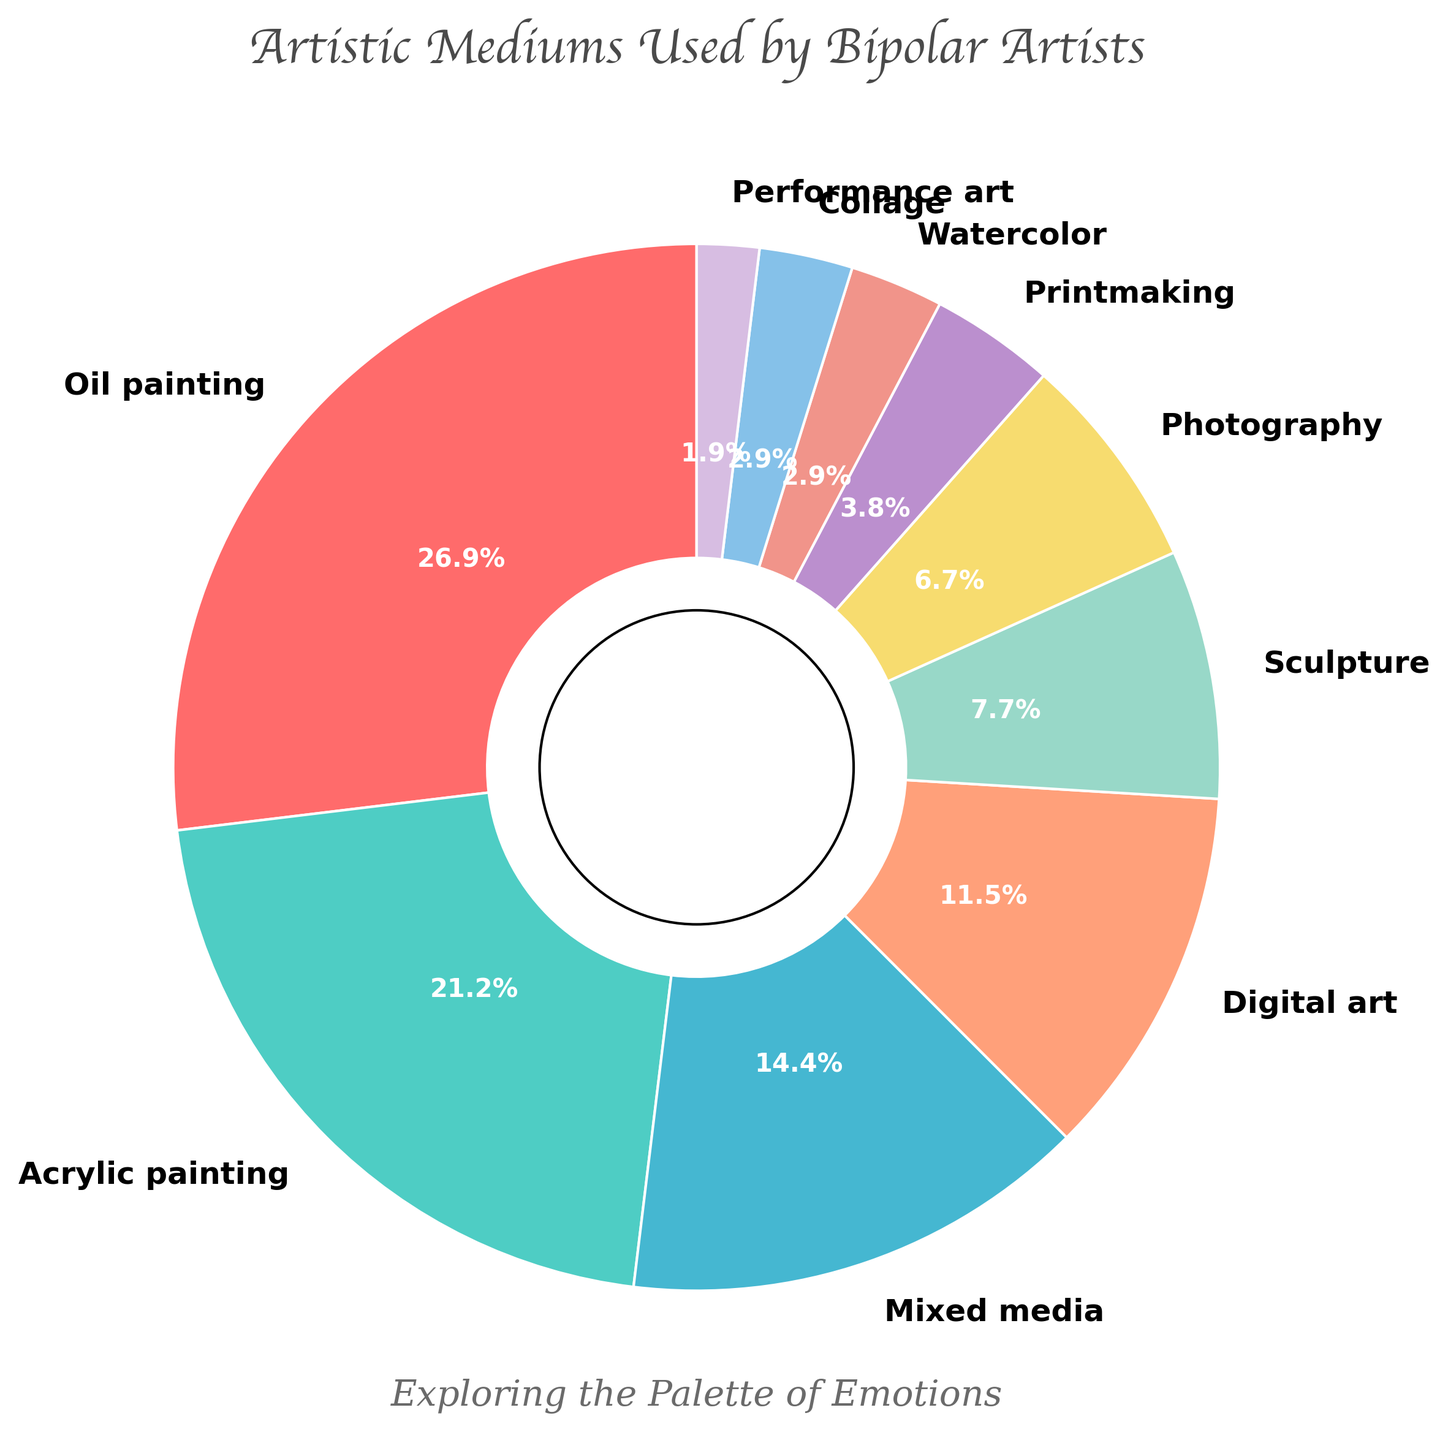what is the most popular artistic medium among bipolar artists? The largest section of the pie chart, identified by the size of the wedge and the label, represents the most popular medium. In this case, the largest wedge indicates that oil painting is the most popular.
Answer: oil painting which mediums make up less than 5% of the distribution? By examining the pie chart and identifying the wedges labeled with percentages less than 5%, we find that printmaking, watercolor, collage, and performance art fall into this category.
Answer: printmaking, watercolor, collage, performance art how much more popular is oil painting compared to sculpture? First, we identify the percentages for oil painting (28%) and sculpture (8%). Then, we subtract the percentage for sculpture from that for oil painting: 28% - 8% = 20%.
Answer: 20% combine the percentages of all painting mediums (oil, acrylic, watercolor). what is their total percentage? We add the percentages of oil painting (28%), acrylic painting (22%), and watercolor (3%): 28% + 22% + 3% = 53%.
Answer: 53% what medium has the closest percentage to digital art? By looking at the percentages in the pie chart, we see that mixed media has a percentage close to that of digital art. Mixed media is 15%, and digital art is 12%.
Answer: mixed media is sculpture more or less popular than photography? We compare the percentages for sculpture (8%) and photography (7%). Since 8% is greater than 7%, sculpture is more popular than photography.
Answer: more which three mediums are least popular? We identify the three smallest wedges in the pie chart, which represent performance art, watercolor, and collage, each with very small percentages (2%, 3%, and 3% respectively).
Answer: performance art, watercolor, collage what percentage of artists use non-painting mediums (excluding oil, acrylic, watercolor)? We sum the percentages for mixed media, digital art, sculpture, photography, printmaking, collage, and performance art: 15% + 12% + 8% + 7% + 4% + 3% + 2% = 51%.
Answer: 51% compare the total percentage of artists using digital art and mixed media to those using oil painting. which total is higher? The combined percentage for digital art and mixed media is 12% + 15% = 27%. Oil painting alone is 28%. Therefore, oil painting's percentage is higher.
Answer: oil painting 